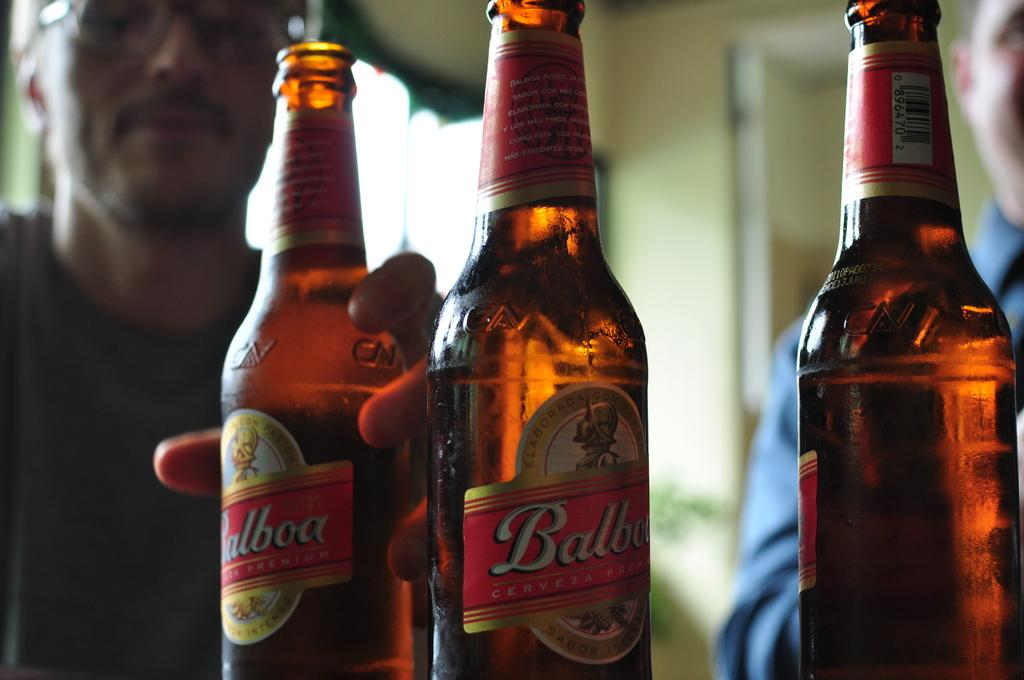<image>
Write a terse but informative summary of the picture. Three opened bottles of Balboa beer are sitting next to each other. 